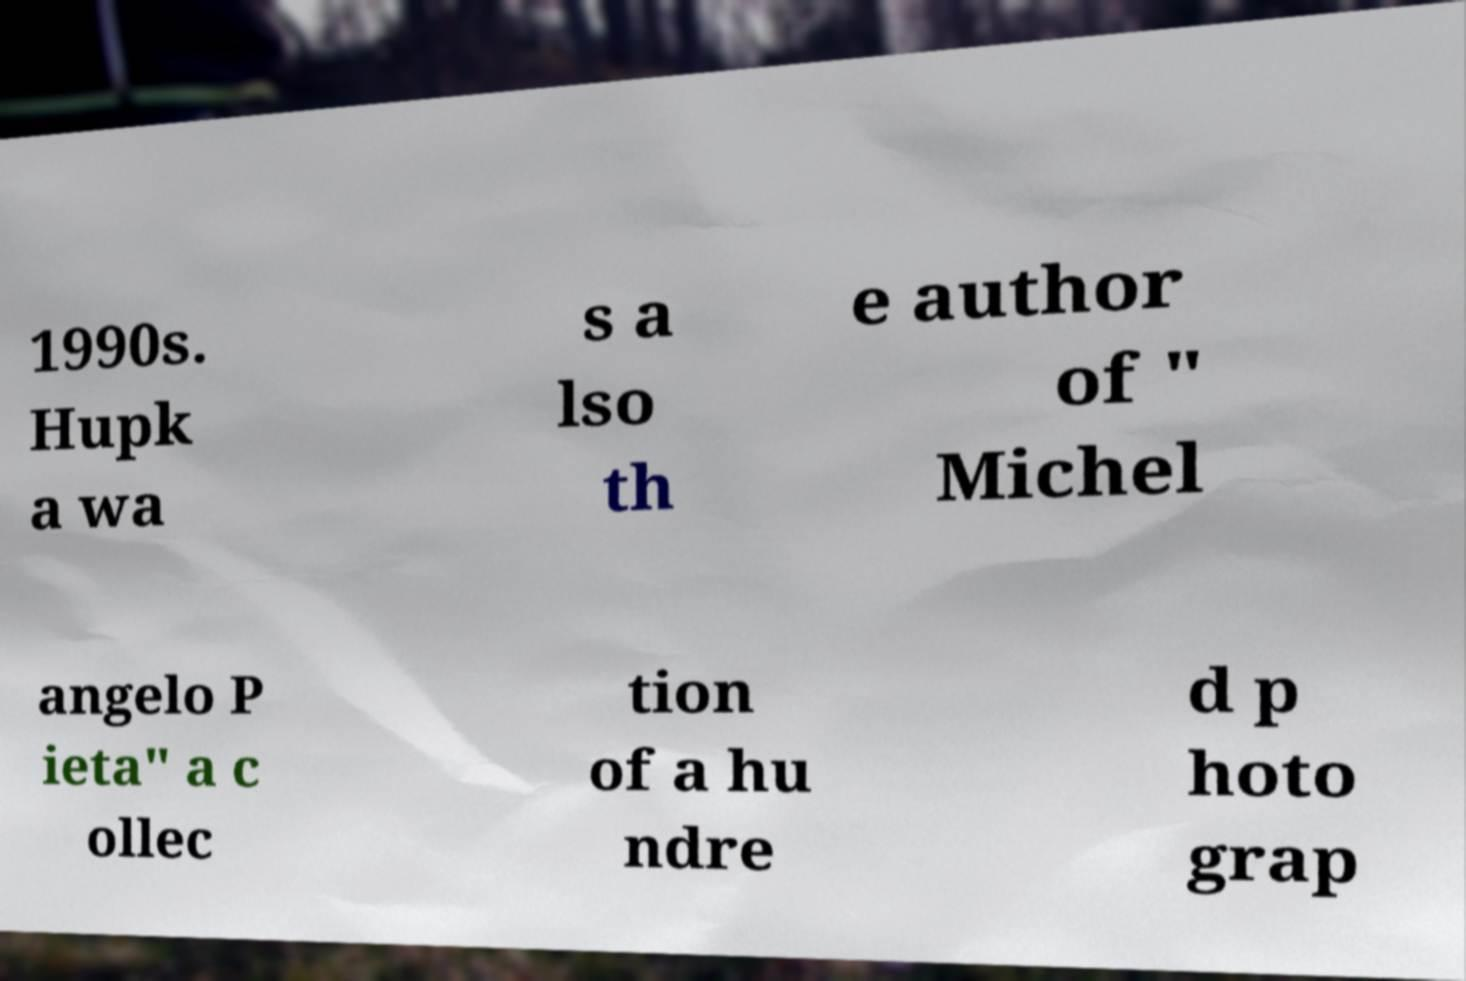Please read and relay the text visible in this image. What does it say? 1990s. Hupk a wa s a lso th e author of " Michel angelo P ieta" a c ollec tion of a hu ndre d p hoto grap 